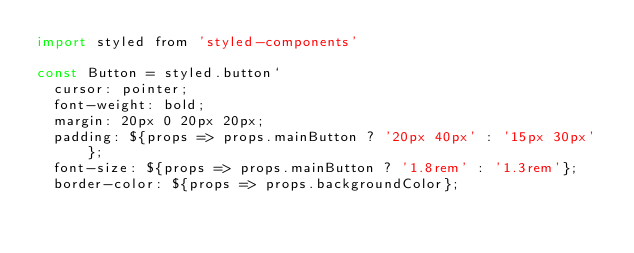<code> <loc_0><loc_0><loc_500><loc_500><_JavaScript_>import styled from 'styled-components'

const Button = styled.button`
  cursor: pointer;
  font-weight: bold;
  margin: 20px 0 20px 20px;
  padding: ${props => props.mainButton ? '20px 40px' : '15px 30px'};
  font-size: ${props => props.mainButton ? '1.8rem' : '1.3rem'};
  border-color: ${props => props.backgroundColor};</code> 